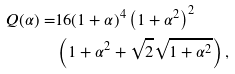<formula> <loc_0><loc_0><loc_500><loc_500>Q ( \alpha ) = & 1 6 ( 1 + \alpha ) ^ { 4 } \left ( 1 + \alpha ^ { 2 } \right ) ^ { 2 } \\ & \left ( 1 + \alpha ^ { 2 } + \sqrt { 2 } \sqrt { 1 + \alpha ^ { 2 } } \right ) ,</formula> 